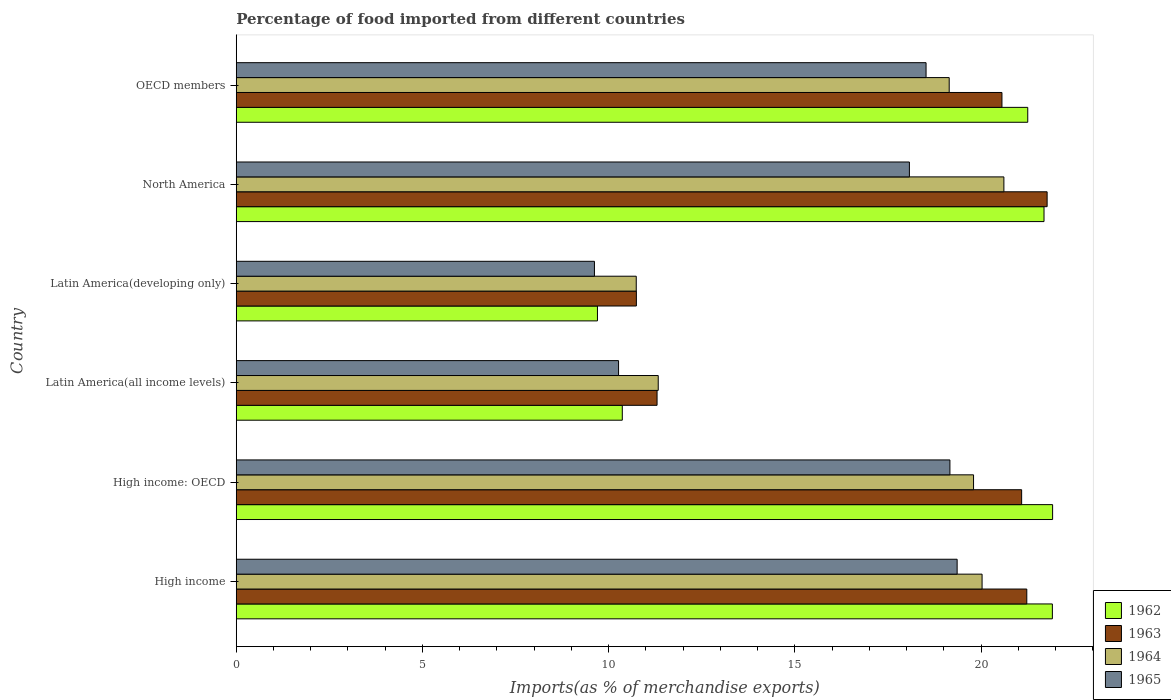Are the number of bars on each tick of the Y-axis equal?
Your answer should be very brief. Yes. How many bars are there on the 4th tick from the top?
Ensure brevity in your answer.  4. What is the label of the 5th group of bars from the top?
Provide a short and direct response. High income: OECD. What is the percentage of imports to different countries in 1964 in Latin America(developing only)?
Offer a very short reply. 10.74. Across all countries, what is the maximum percentage of imports to different countries in 1963?
Provide a succinct answer. 21.77. Across all countries, what is the minimum percentage of imports to different countries in 1965?
Make the answer very short. 9.62. In which country was the percentage of imports to different countries in 1964 maximum?
Provide a short and direct response. North America. In which country was the percentage of imports to different countries in 1962 minimum?
Offer a very short reply. Latin America(developing only). What is the total percentage of imports to different countries in 1962 in the graph?
Your answer should be very brief. 106.83. What is the difference between the percentage of imports to different countries in 1965 in High income and that in North America?
Give a very brief answer. 1.28. What is the difference between the percentage of imports to different countries in 1962 in High income and the percentage of imports to different countries in 1963 in North America?
Your answer should be very brief. 0.14. What is the average percentage of imports to different countries in 1962 per country?
Your response must be concise. 17.81. What is the difference between the percentage of imports to different countries in 1964 and percentage of imports to different countries in 1962 in North America?
Offer a very short reply. -1.08. What is the ratio of the percentage of imports to different countries in 1964 in High income: OECD to that in OECD members?
Keep it short and to the point. 1.03. What is the difference between the highest and the second highest percentage of imports to different countries in 1964?
Keep it short and to the point. 0.59. What is the difference between the highest and the lowest percentage of imports to different countries in 1963?
Your answer should be compact. 11.03. In how many countries, is the percentage of imports to different countries in 1965 greater than the average percentage of imports to different countries in 1965 taken over all countries?
Your answer should be very brief. 4. Is the sum of the percentage of imports to different countries in 1962 in Latin America(developing only) and North America greater than the maximum percentage of imports to different countries in 1964 across all countries?
Give a very brief answer. Yes. What does the 2nd bar from the top in Latin America(all income levels) represents?
Provide a succinct answer. 1964. What does the 3rd bar from the bottom in Latin America(developing only) represents?
Keep it short and to the point. 1964. How many bars are there?
Your answer should be very brief. 24. Are all the bars in the graph horizontal?
Your answer should be very brief. Yes. Are the values on the major ticks of X-axis written in scientific E-notation?
Provide a short and direct response. No. Where does the legend appear in the graph?
Make the answer very short. Bottom right. What is the title of the graph?
Your answer should be compact. Percentage of food imported from different countries. Does "1984" appear as one of the legend labels in the graph?
Give a very brief answer. No. What is the label or title of the X-axis?
Your response must be concise. Imports(as % of merchandise exports). What is the label or title of the Y-axis?
Offer a very short reply. Country. What is the Imports(as % of merchandise exports) in 1962 in High income?
Your answer should be very brief. 21.91. What is the Imports(as % of merchandise exports) in 1963 in High income?
Give a very brief answer. 21.23. What is the Imports(as % of merchandise exports) of 1964 in High income?
Provide a short and direct response. 20.02. What is the Imports(as % of merchandise exports) in 1965 in High income?
Keep it short and to the point. 19.36. What is the Imports(as % of merchandise exports) of 1962 in High income: OECD?
Provide a short and direct response. 21.92. What is the Imports(as % of merchandise exports) of 1963 in High income: OECD?
Offer a terse response. 21.09. What is the Imports(as % of merchandise exports) of 1964 in High income: OECD?
Give a very brief answer. 19.8. What is the Imports(as % of merchandise exports) of 1965 in High income: OECD?
Ensure brevity in your answer.  19.16. What is the Imports(as % of merchandise exports) in 1962 in Latin America(all income levels)?
Your answer should be very brief. 10.36. What is the Imports(as % of merchandise exports) in 1963 in Latin America(all income levels)?
Keep it short and to the point. 11.3. What is the Imports(as % of merchandise exports) of 1964 in Latin America(all income levels)?
Provide a succinct answer. 11.33. What is the Imports(as % of merchandise exports) in 1965 in Latin America(all income levels)?
Give a very brief answer. 10.26. What is the Imports(as % of merchandise exports) of 1962 in Latin America(developing only)?
Your answer should be compact. 9.7. What is the Imports(as % of merchandise exports) in 1963 in Latin America(developing only)?
Offer a very short reply. 10.74. What is the Imports(as % of merchandise exports) of 1964 in Latin America(developing only)?
Provide a short and direct response. 10.74. What is the Imports(as % of merchandise exports) in 1965 in Latin America(developing only)?
Ensure brevity in your answer.  9.62. What is the Imports(as % of merchandise exports) in 1962 in North America?
Give a very brief answer. 21.69. What is the Imports(as % of merchandise exports) in 1963 in North America?
Provide a succinct answer. 21.77. What is the Imports(as % of merchandise exports) of 1964 in North America?
Your answer should be compact. 20.61. What is the Imports(as % of merchandise exports) in 1965 in North America?
Give a very brief answer. 18.07. What is the Imports(as % of merchandise exports) in 1962 in OECD members?
Your answer should be compact. 21.25. What is the Imports(as % of merchandise exports) of 1963 in OECD members?
Your response must be concise. 20.56. What is the Imports(as % of merchandise exports) in 1964 in OECD members?
Give a very brief answer. 19.14. What is the Imports(as % of merchandise exports) in 1965 in OECD members?
Offer a terse response. 18.52. Across all countries, what is the maximum Imports(as % of merchandise exports) of 1962?
Keep it short and to the point. 21.92. Across all countries, what is the maximum Imports(as % of merchandise exports) in 1963?
Offer a very short reply. 21.77. Across all countries, what is the maximum Imports(as % of merchandise exports) of 1964?
Your answer should be very brief. 20.61. Across all countries, what is the maximum Imports(as % of merchandise exports) in 1965?
Keep it short and to the point. 19.36. Across all countries, what is the minimum Imports(as % of merchandise exports) in 1962?
Your response must be concise. 9.7. Across all countries, what is the minimum Imports(as % of merchandise exports) in 1963?
Your answer should be compact. 10.74. Across all countries, what is the minimum Imports(as % of merchandise exports) of 1964?
Offer a very short reply. 10.74. Across all countries, what is the minimum Imports(as % of merchandise exports) of 1965?
Offer a very short reply. 9.62. What is the total Imports(as % of merchandise exports) of 1962 in the graph?
Give a very brief answer. 106.83. What is the total Imports(as % of merchandise exports) in 1963 in the graph?
Make the answer very short. 106.68. What is the total Imports(as % of merchandise exports) in 1964 in the graph?
Keep it short and to the point. 101.64. What is the total Imports(as % of merchandise exports) of 1965 in the graph?
Your answer should be compact. 94.99. What is the difference between the Imports(as % of merchandise exports) of 1962 in High income and that in High income: OECD?
Ensure brevity in your answer.  -0.01. What is the difference between the Imports(as % of merchandise exports) of 1963 in High income and that in High income: OECD?
Offer a terse response. 0.14. What is the difference between the Imports(as % of merchandise exports) of 1964 in High income and that in High income: OECD?
Your answer should be very brief. 0.23. What is the difference between the Imports(as % of merchandise exports) in 1965 in High income and that in High income: OECD?
Provide a short and direct response. 0.19. What is the difference between the Imports(as % of merchandise exports) of 1962 in High income and that in Latin America(all income levels)?
Your answer should be compact. 11.55. What is the difference between the Imports(as % of merchandise exports) in 1963 in High income and that in Latin America(all income levels)?
Offer a very short reply. 9.93. What is the difference between the Imports(as % of merchandise exports) of 1964 in High income and that in Latin America(all income levels)?
Your response must be concise. 8.7. What is the difference between the Imports(as % of merchandise exports) of 1965 in High income and that in Latin America(all income levels)?
Your answer should be very brief. 9.09. What is the difference between the Imports(as % of merchandise exports) of 1962 in High income and that in Latin America(developing only)?
Your response must be concise. 12.21. What is the difference between the Imports(as % of merchandise exports) in 1963 in High income and that in Latin America(developing only)?
Give a very brief answer. 10.48. What is the difference between the Imports(as % of merchandise exports) of 1964 in High income and that in Latin America(developing only)?
Your answer should be very brief. 9.29. What is the difference between the Imports(as % of merchandise exports) in 1965 in High income and that in Latin America(developing only)?
Provide a short and direct response. 9.74. What is the difference between the Imports(as % of merchandise exports) of 1962 in High income and that in North America?
Provide a succinct answer. 0.22. What is the difference between the Imports(as % of merchandise exports) in 1963 in High income and that in North America?
Provide a succinct answer. -0.55. What is the difference between the Imports(as % of merchandise exports) of 1964 in High income and that in North America?
Give a very brief answer. -0.59. What is the difference between the Imports(as % of merchandise exports) of 1965 in High income and that in North America?
Ensure brevity in your answer.  1.28. What is the difference between the Imports(as % of merchandise exports) in 1962 in High income and that in OECD members?
Give a very brief answer. 0.66. What is the difference between the Imports(as % of merchandise exports) of 1963 in High income and that in OECD members?
Offer a very short reply. 0.67. What is the difference between the Imports(as % of merchandise exports) in 1964 in High income and that in OECD members?
Make the answer very short. 0.88. What is the difference between the Imports(as % of merchandise exports) in 1965 in High income and that in OECD members?
Your response must be concise. 0.83. What is the difference between the Imports(as % of merchandise exports) in 1962 in High income: OECD and that in Latin America(all income levels)?
Offer a very short reply. 11.55. What is the difference between the Imports(as % of merchandise exports) of 1963 in High income: OECD and that in Latin America(all income levels)?
Your answer should be compact. 9.79. What is the difference between the Imports(as % of merchandise exports) of 1964 in High income: OECD and that in Latin America(all income levels)?
Provide a short and direct response. 8.47. What is the difference between the Imports(as % of merchandise exports) in 1965 in High income: OECD and that in Latin America(all income levels)?
Offer a very short reply. 8.9. What is the difference between the Imports(as % of merchandise exports) of 1962 in High income: OECD and that in Latin America(developing only)?
Give a very brief answer. 12.22. What is the difference between the Imports(as % of merchandise exports) in 1963 in High income: OECD and that in Latin America(developing only)?
Make the answer very short. 10.34. What is the difference between the Imports(as % of merchandise exports) in 1964 in High income: OECD and that in Latin America(developing only)?
Ensure brevity in your answer.  9.06. What is the difference between the Imports(as % of merchandise exports) in 1965 in High income: OECD and that in Latin America(developing only)?
Provide a short and direct response. 9.54. What is the difference between the Imports(as % of merchandise exports) in 1962 in High income: OECD and that in North America?
Keep it short and to the point. 0.23. What is the difference between the Imports(as % of merchandise exports) of 1963 in High income: OECD and that in North America?
Give a very brief answer. -0.68. What is the difference between the Imports(as % of merchandise exports) of 1964 in High income: OECD and that in North America?
Provide a short and direct response. -0.81. What is the difference between the Imports(as % of merchandise exports) of 1965 in High income: OECD and that in North America?
Your response must be concise. 1.09. What is the difference between the Imports(as % of merchandise exports) in 1962 in High income: OECD and that in OECD members?
Keep it short and to the point. 0.67. What is the difference between the Imports(as % of merchandise exports) of 1963 in High income: OECD and that in OECD members?
Provide a succinct answer. 0.53. What is the difference between the Imports(as % of merchandise exports) of 1964 in High income: OECD and that in OECD members?
Ensure brevity in your answer.  0.65. What is the difference between the Imports(as % of merchandise exports) in 1965 in High income: OECD and that in OECD members?
Your answer should be compact. 0.64. What is the difference between the Imports(as % of merchandise exports) of 1962 in Latin America(all income levels) and that in Latin America(developing only)?
Give a very brief answer. 0.67. What is the difference between the Imports(as % of merchandise exports) in 1963 in Latin America(all income levels) and that in Latin America(developing only)?
Make the answer very short. 0.56. What is the difference between the Imports(as % of merchandise exports) of 1964 in Latin America(all income levels) and that in Latin America(developing only)?
Give a very brief answer. 0.59. What is the difference between the Imports(as % of merchandise exports) of 1965 in Latin America(all income levels) and that in Latin America(developing only)?
Ensure brevity in your answer.  0.65. What is the difference between the Imports(as % of merchandise exports) of 1962 in Latin America(all income levels) and that in North America?
Your response must be concise. -11.32. What is the difference between the Imports(as % of merchandise exports) in 1963 in Latin America(all income levels) and that in North America?
Offer a terse response. -10.47. What is the difference between the Imports(as % of merchandise exports) in 1964 in Latin America(all income levels) and that in North America?
Your response must be concise. -9.28. What is the difference between the Imports(as % of merchandise exports) in 1965 in Latin America(all income levels) and that in North America?
Ensure brevity in your answer.  -7.81. What is the difference between the Imports(as % of merchandise exports) of 1962 in Latin America(all income levels) and that in OECD members?
Provide a succinct answer. -10.89. What is the difference between the Imports(as % of merchandise exports) of 1963 in Latin America(all income levels) and that in OECD members?
Give a very brief answer. -9.26. What is the difference between the Imports(as % of merchandise exports) in 1964 in Latin America(all income levels) and that in OECD members?
Provide a succinct answer. -7.81. What is the difference between the Imports(as % of merchandise exports) of 1965 in Latin America(all income levels) and that in OECD members?
Your answer should be very brief. -8.26. What is the difference between the Imports(as % of merchandise exports) of 1962 in Latin America(developing only) and that in North America?
Provide a short and direct response. -11.99. What is the difference between the Imports(as % of merchandise exports) of 1963 in Latin America(developing only) and that in North America?
Provide a short and direct response. -11.03. What is the difference between the Imports(as % of merchandise exports) of 1964 in Latin America(developing only) and that in North America?
Give a very brief answer. -9.87. What is the difference between the Imports(as % of merchandise exports) of 1965 in Latin America(developing only) and that in North America?
Provide a short and direct response. -8.46. What is the difference between the Imports(as % of merchandise exports) in 1962 in Latin America(developing only) and that in OECD members?
Make the answer very short. -11.55. What is the difference between the Imports(as % of merchandise exports) in 1963 in Latin America(developing only) and that in OECD members?
Provide a succinct answer. -9.82. What is the difference between the Imports(as % of merchandise exports) of 1964 in Latin America(developing only) and that in OECD members?
Offer a very short reply. -8.4. What is the difference between the Imports(as % of merchandise exports) in 1965 in Latin America(developing only) and that in OECD members?
Offer a very short reply. -8.9. What is the difference between the Imports(as % of merchandise exports) in 1962 in North America and that in OECD members?
Make the answer very short. 0.44. What is the difference between the Imports(as % of merchandise exports) of 1963 in North America and that in OECD members?
Give a very brief answer. 1.21. What is the difference between the Imports(as % of merchandise exports) of 1964 in North America and that in OECD members?
Ensure brevity in your answer.  1.47. What is the difference between the Imports(as % of merchandise exports) in 1965 in North America and that in OECD members?
Make the answer very short. -0.45. What is the difference between the Imports(as % of merchandise exports) in 1962 in High income and the Imports(as % of merchandise exports) in 1963 in High income: OECD?
Your answer should be compact. 0.83. What is the difference between the Imports(as % of merchandise exports) of 1962 in High income and the Imports(as % of merchandise exports) of 1964 in High income: OECD?
Keep it short and to the point. 2.12. What is the difference between the Imports(as % of merchandise exports) in 1962 in High income and the Imports(as % of merchandise exports) in 1965 in High income: OECD?
Make the answer very short. 2.75. What is the difference between the Imports(as % of merchandise exports) of 1963 in High income and the Imports(as % of merchandise exports) of 1964 in High income: OECD?
Make the answer very short. 1.43. What is the difference between the Imports(as % of merchandise exports) of 1963 in High income and the Imports(as % of merchandise exports) of 1965 in High income: OECD?
Provide a succinct answer. 2.06. What is the difference between the Imports(as % of merchandise exports) in 1964 in High income and the Imports(as % of merchandise exports) in 1965 in High income: OECD?
Give a very brief answer. 0.86. What is the difference between the Imports(as % of merchandise exports) of 1962 in High income and the Imports(as % of merchandise exports) of 1963 in Latin America(all income levels)?
Give a very brief answer. 10.61. What is the difference between the Imports(as % of merchandise exports) in 1962 in High income and the Imports(as % of merchandise exports) in 1964 in Latin America(all income levels)?
Provide a short and direct response. 10.58. What is the difference between the Imports(as % of merchandise exports) in 1962 in High income and the Imports(as % of merchandise exports) in 1965 in Latin America(all income levels)?
Provide a succinct answer. 11.65. What is the difference between the Imports(as % of merchandise exports) in 1963 in High income and the Imports(as % of merchandise exports) in 1964 in Latin America(all income levels)?
Keep it short and to the point. 9.9. What is the difference between the Imports(as % of merchandise exports) of 1963 in High income and the Imports(as % of merchandise exports) of 1965 in Latin America(all income levels)?
Your answer should be very brief. 10.96. What is the difference between the Imports(as % of merchandise exports) of 1964 in High income and the Imports(as % of merchandise exports) of 1965 in Latin America(all income levels)?
Keep it short and to the point. 9.76. What is the difference between the Imports(as % of merchandise exports) in 1962 in High income and the Imports(as % of merchandise exports) in 1963 in Latin America(developing only)?
Ensure brevity in your answer.  11.17. What is the difference between the Imports(as % of merchandise exports) in 1962 in High income and the Imports(as % of merchandise exports) in 1964 in Latin America(developing only)?
Provide a short and direct response. 11.17. What is the difference between the Imports(as % of merchandise exports) in 1962 in High income and the Imports(as % of merchandise exports) in 1965 in Latin America(developing only)?
Make the answer very short. 12.3. What is the difference between the Imports(as % of merchandise exports) in 1963 in High income and the Imports(as % of merchandise exports) in 1964 in Latin America(developing only)?
Ensure brevity in your answer.  10.49. What is the difference between the Imports(as % of merchandise exports) in 1963 in High income and the Imports(as % of merchandise exports) in 1965 in Latin America(developing only)?
Provide a succinct answer. 11.61. What is the difference between the Imports(as % of merchandise exports) of 1964 in High income and the Imports(as % of merchandise exports) of 1965 in Latin America(developing only)?
Give a very brief answer. 10.41. What is the difference between the Imports(as % of merchandise exports) in 1962 in High income and the Imports(as % of merchandise exports) in 1963 in North America?
Your response must be concise. 0.14. What is the difference between the Imports(as % of merchandise exports) of 1962 in High income and the Imports(as % of merchandise exports) of 1964 in North America?
Ensure brevity in your answer.  1.3. What is the difference between the Imports(as % of merchandise exports) of 1962 in High income and the Imports(as % of merchandise exports) of 1965 in North America?
Offer a terse response. 3.84. What is the difference between the Imports(as % of merchandise exports) in 1963 in High income and the Imports(as % of merchandise exports) in 1964 in North America?
Make the answer very short. 0.61. What is the difference between the Imports(as % of merchandise exports) in 1963 in High income and the Imports(as % of merchandise exports) in 1965 in North America?
Offer a terse response. 3.15. What is the difference between the Imports(as % of merchandise exports) of 1964 in High income and the Imports(as % of merchandise exports) of 1965 in North America?
Offer a very short reply. 1.95. What is the difference between the Imports(as % of merchandise exports) in 1962 in High income and the Imports(as % of merchandise exports) in 1963 in OECD members?
Offer a very short reply. 1.35. What is the difference between the Imports(as % of merchandise exports) of 1962 in High income and the Imports(as % of merchandise exports) of 1964 in OECD members?
Give a very brief answer. 2.77. What is the difference between the Imports(as % of merchandise exports) of 1962 in High income and the Imports(as % of merchandise exports) of 1965 in OECD members?
Make the answer very short. 3.39. What is the difference between the Imports(as % of merchandise exports) in 1963 in High income and the Imports(as % of merchandise exports) in 1964 in OECD members?
Offer a terse response. 2.08. What is the difference between the Imports(as % of merchandise exports) in 1963 in High income and the Imports(as % of merchandise exports) in 1965 in OECD members?
Your answer should be compact. 2.7. What is the difference between the Imports(as % of merchandise exports) in 1964 in High income and the Imports(as % of merchandise exports) in 1965 in OECD members?
Your answer should be compact. 1.5. What is the difference between the Imports(as % of merchandise exports) of 1962 in High income: OECD and the Imports(as % of merchandise exports) of 1963 in Latin America(all income levels)?
Keep it short and to the point. 10.62. What is the difference between the Imports(as % of merchandise exports) of 1962 in High income: OECD and the Imports(as % of merchandise exports) of 1964 in Latin America(all income levels)?
Provide a succinct answer. 10.59. What is the difference between the Imports(as % of merchandise exports) in 1962 in High income: OECD and the Imports(as % of merchandise exports) in 1965 in Latin America(all income levels)?
Give a very brief answer. 11.65. What is the difference between the Imports(as % of merchandise exports) of 1963 in High income: OECD and the Imports(as % of merchandise exports) of 1964 in Latin America(all income levels)?
Ensure brevity in your answer.  9.76. What is the difference between the Imports(as % of merchandise exports) in 1963 in High income: OECD and the Imports(as % of merchandise exports) in 1965 in Latin America(all income levels)?
Your answer should be compact. 10.82. What is the difference between the Imports(as % of merchandise exports) of 1964 in High income: OECD and the Imports(as % of merchandise exports) of 1965 in Latin America(all income levels)?
Offer a very short reply. 9.53. What is the difference between the Imports(as % of merchandise exports) of 1962 in High income: OECD and the Imports(as % of merchandise exports) of 1963 in Latin America(developing only)?
Make the answer very short. 11.18. What is the difference between the Imports(as % of merchandise exports) of 1962 in High income: OECD and the Imports(as % of merchandise exports) of 1964 in Latin America(developing only)?
Give a very brief answer. 11.18. What is the difference between the Imports(as % of merchandise exports) of 1962 in High income: OECD and the Imports(as % of merchandise exports) of 1965 in Latin America(developing only)?
Provide a short and direct response. 12.3. What is the difference between the Imports(as % of merchandise exports) in 1963 in High income: OECD and the Imports(as % of merchandise exports) in 1964 in Latin America(developing only)?
Offer a very short reply. 10.35. What is the difference between the Imports(as % of merchandise exports) of 1963 in High income: OECD and the Imports(as % of merchandise exports) of 1965 in Latin America(developing only)?
Make the answer very short. 11.47. What is the difference between the Imports(as % of merchandise exports) of 1964 in High income: OECD and the Imports(as % of merchandise exports) of 1965 in Latin America(developing only)?
Give a very brief answer. 10.18. What is the difference between the Imports(as % of merchandise exports) of 1962 in High income: OECD and the Imports(as % of merchandise exports) of 1963 in North America?
Make the answer very short. 0.15. What is the difference between the Imports(as % of merchandise exports) in 1962 in High income: OECD and the Imports(as % of merchandise exports) in 1964 in North America?
Offer a terse response. 1.31. What is the difference between the Imports(as % of merchandise exports) in 1962 in High income: OECD and the Imports(as % of merchandise exports) in 1965 in North America?
Give a very brief answer. 3.84. What is the difference between the Imports(as % of merchandise exports) of 1963 in High income: OECD and the Imports(as % of merchandise exports) of 1964 in North America?
Give a very brief answer. 0.48. What is the difference between the Imports(as % of merchandise exports) in 1963 in High income: OECD and the Imports(as % of merchandise exports) in 1965 in North America?
Your answer should be very brief. 3.01. What is the difference between the Imports(as % of merchandise exports) in 1964 in High income: OECD and the Imports(as % of merchandise exports) in 1965 in North America?
Make the answer very short. 1.72. What is the difference between the Imports(as % of merchandise exports) of 1962 in High income: OECD and the Imports(as % of merchandise exports) of 1963 in OECD members?
Give a very brief answer. 1.36. What is the difference between the Imports(as % of merchandise exports) in 1962 in High income: OECD and the Imports(as % of merchandise exports) in 1964 in OECD members?
Keep it short and to the point. 2.78. What is the difference between the Imports(as % of merchandise exports) in 1962 in High income: OECD and the Imports(as % of merchandise exports) in 1965 in OECD members?
Your response must be concise. 3.4. What is the difference between the Imports(as % of merchandise exports) in 1963 in High income: OECD and the Imports(as % of merchandise exports) in 1964 in OECD members?
Your answer should be compact. 1.94. What is the difference between the Imports(as % of merchandise exports) of 1963 in High income: OECD and the Imports(as % of merchandise exports) of 1965 in OECD members?
Make the answer very short. 2.57. What is the difference between the Imports(as % of merchandise exports) in 1964 in High income: OECD and the Imports(as % of merchandise exports) in 1965 in OECD members?
Keep it short and to the point. 1.27. What is the difference between the Imports(as % of merchandise exports) in 1962 in Latin America(all income levels) and the Imports(as % of merchandise exports) in 1963 in Latin America(developing only)?
Your response must be concise. -0.38. What is the difference between the Imports(as % of merchandise exports) in 1962 in Latin America(all income levels) and the Imports(as % of merchandise exports) in 1964 in Latin America(developing only)?
Provide a short and direct response. -0.37. What is the difference between the Imports(as % of merchandise exports) of 1962 in Latin America(all income levels) and the Imports(as % of merchandise exports) of 1965 in Latin America(developing only)?
Ensure brevity in your answer.  0.75. What is the difference between the Imports(as % of merchandise exports) of 1963 in Latin America(all income levels) and the Imports(as % of merchandise exports) of 1964 in Latin America(developing only)?
Provide a short and direct response. 0.56. What is the difference between the Imports(as % of merchandise exports) in 1963 in Latin America(all income levels) and the Imports(as % of merchandise exports) in 1965 in Latin America(developing only)?
Your answer should be very brief. 1.68. What is the difference between the Imports(as % of merchandise exports) in 1964 in Latin America(all income levels) and the Imports(as % of merchandise exports) in 1965 in Latin America(developing only)?
Make the answer very short. 1.71. What is the difference between the Imports(as % of merchandise exports) in 1962 in Latin America(all income levels) and the Imports(as % of merchandise exports) in 1963 in North America?
Make the answer very short. -11.41. What is the difference between the Imports(as % of merchandise exports) in 1962 in Latin America(all income levels) and the Imports(as % of merchandise exports) in 1964 in North America?
Provide a short and direct response. -10.25. What is the difference between the Imports(as % of merchandise exports) of 1962 in Latin America(all income levels) and the Imports(as % of merchandise exports) of 1965 in North America?
Give a very brief answer. -7.71. What is the difference between the Imports(as % of merchandise exports) of 1963 in Latin America(all income levels) and the Imports(as % of merchandise exports) of 1964 in North America?
Keep it short and to the point. -9.31. What is the difference between the Imports(as % of merchandise exports) of 1963 in Latin America(all income levels) and the Imports(as % of merchandise exports) of 1965 in North America?
Your response must be concise. -6.78. What is the difference between the Imports(as % of merchandise exports) of 1964 in Latin America(all income levels) and the Imports(as % of merchandise exports) of 1965 in North America?
Offer a terse response. -6.74. What is the difference between the Imports(as % of merchandise exports) in 1962 in Latin America(all income levels) and the Imports(as % of merchandise exports) in 1963 in OECD members?
Give a very brief answer. -10.19. What is the difference between the Imports(as % of merchandise exports) in 1962 in Latin America(all income levels) and the Imports(as % of merchandise exports) in 1964 in OECD members?
Your answer should be compact. -8.78. What is the difference between the Imports(as % of merchandise exports) in 1962 in Latin America(all income levels) and the Imports(as % of merchandise exports) in 1965 in OECD members?
Your answer should be compact. -8.16. What is the difference between the Imports(as % of merchandise exports) in 1963 in Latin America(all income levels) and the Imports(as % of merchandise exports) in 1964 in OECD members?
Provide a short and direct response. -7.84. What is the difference between the Imports(as % of merchandise exports) in 1963 in Latin America(all income levels) and the Imports(as % of merchandise exports) in 1965 in OECD members?
Your response must be concise. -7.22. What is the difference between the Imports(as % of merchandise exports) in 1964 in Latin America(all income levels) and the Imports(as % of merchandise exports) in 1965 in OECD members?
Make the answer very short. -7.19. What is the difference between the Imports(as % of merchandise exports) of 1962 in Latin America(developing only) and the Imports(as % of merchandise exports) of 1963 in North America?
Provide a short and direct response. -12.07. What is the difference between the Imports(as % of merchandise exports) in 1962 in Latin America(developing only) and the Imports(as % of merchandise exports) in 1964 in North America?
Offer a very short reply. -10.91. What is the difference between the Imports(as % of merchandise exports) in 1962 in Latin America(developing only) and the Imports(as % of merchandise exports) in 1965 in North America?
Offer a very short reply. -8.38. What is the difference between the Imports(as % of merchandise exports) of 1963 in Latin America(developing only) and the Imports(as % of merchandise exports) of 1964 in North America?
Keep it short and to the point. -9.87. What is the difference between the Imports(as % of merchandise exports) of 1963 in Latin America(developing only) and the Imports(as % of merchandise exports) of 1965 in North America?
Keep it short and to the point. -7.33. What is the difference between the Imports(as % of merchandise exports) in 1964 in Latin America(developing only) and the Imports(as % of merchandise exports) in 1965 in North America?
Your answer should be compact. -7.33. What is the difference between the Imports(as % of merchandise exports) of 1962 in Latin America(developing only) and the Imports(as % of merchandise exports) of 1963 in OECD members?
Offer a terse response. -10.86. What is the difference between the Imports(as % of merchandise exports) of 1962 in Latin America(developing only) and the Imports(as % of merchandise exports) of 1964 in OECD members?
Provide a short and direct response. -9.44. What is the difference between the Imports(as % of merchandise exports) of 1962 in Latin America(developing only) and the Imports(as % of merchandise exports) of 1965 in OECD members?
Your answer should be very brief. -8.82. What is the difference between the Imports(as % of merchandise exports) in 1963 in Latin America(developing only) and the Imports(as % of merchandise exports) in 1964 in OECD members?
Offer a terse response. -8.4. What is the difference between the Imports(as % of merchandise exports) of 1963 in Latin America(developing only) and the Imports(as % of merchandise exports) of 1965 in OECD members?
Your answer should be very brief. -7.78. What is the difference between the Imports(as % of merchandise exports) of 1964 in Latin America(developing only) and the Imports(as % of merchandise exports) of 1965 in OECD members?
Keep it short and to the point. -7.78. What is the difference between the Imports(as % of merchandise exports) of 1962 in North America and the Imports(as % of merchandise exports) of 1963 in OECD members?
Your answer should be compact. 1.13. What is the difference between the Imports(as % of merchandise exports) of 1962 in North America and the Imports(as % of merchandise exports) of 1964 in OECD members?
Give a very brief answer. 2.55. What is the difference between the Imports(as % of merchandise exports) in 1962 in North America and the Imports(as % of merchandise exports) in 1965 in OECD members?
Your answer should be compact. 3.17. What is the difference between the Imports(as % of merchandise exports) in 1963 in North America and the Imports(as % of merchandise exports) in 1964 in OECD members?
Your answer should be compact. 2.63. What is the difference between the Imports(as % of merchandise exports) in 1963 in North America and the Imports(as % of merchandise exports) in 1965 in OECD members?
Make the answer very short. 3.25. What is the difference between the Imports(as % of merchandise exports) in 1964 in North America and the Imports(as % of merchandise exports) in 1965 in OECD members?
Offer a very short reply. 2.09. What is the average Imports(as % of merchandise exports) in 1962 per country?
Provide a short and direct response. 17.81. What is the average Imports(as % of merchandise exports) in 1963 per country?
Keep it short and to the point. 17.78. What is the average Imports(as % of merchandise exports) of 1964 per country?
Ensure brevity in your answer.  16.94. What is the average Imports(as % of merchandise exports) of 1965 per country?
Keep it short and to the point. 15.83. What is the difference between the Imports(as % of merchandise exports) in 1962 and Imports(as % of merchandise exports) in 1963 in High income?
Your answer should be compact. 0.69. What is the difference between the Imports(as % of merchandise exports) of 1962 and Imports(as % of merchandise exports) of 1964 in High income?
Offer a very short reply. 1.89. What is the difference between the Imports(as % of merchandise exports) in 1962 and Imports(as % of merchandise exports) in 1965 in High income?
Your response must be concise. 2.56. What is the difference between the Imports(as % of merchandise exports) in 1963 and Imports(as % of merchandise exports) in 1964 in High income?
Your answer should be compact. 1.2. What is the difference between the Imports(as % of merchandise exports) of 1963 and Imports(as % of merchandise exports) of 1965 in High income?
Give a very brief answer. 1.87. What is the difference between the Imports(as % of merchandise exports) of 1964 and Imports(as % of merchandise exports) of 1965 in High income?
Offer a terse response. 0.67. What is the difference between the Imports(as % of merchandise exports) in 1962 and Imports(as % of merchandise exports) in 1963 in High income: OECD?
Provide a short and direct response. 0.83. What is the difference between the Imports(as % of merchandise exports) of 1962 and Imports(as % of merchandise exports) of 1964 in High income: OECD?
Your response must be concise. 2.12. What is the difference between the Imports(as % of merchandise exports) in 1962 and Imports(as % of merchandise exports) in 1965 in High income: OECD?
Offer a very short reply. 2.76. What is the difference between the Imports(as % of merchandise exports) in 1963 and Imports(as % of merchandise exports) in 1964 in High income: OECD?
Offer a terse response. 1.29. What is the difference between the Imports(as % of merchandise exports) in 1963 and Imports(as % of merchandise exports) in 1965 in High income: OECD?
Offer a very short reply. 1.93. What is the difference between the Imports(as % of merchandise exports) of 1964 and Imports(as % of merchandise exports) of 1965 in High income: OECD?
Provide a short and direct response. 0.63. What is the difference between the Imports(as % of merchandise exports) in 1962 and Imports(as % of merchandise exports) in 1963 in Latin America(all income levels)?
Your answer should be compact. -0.93. What is the difference between the Imports(as % of merchandise exports) of 1962 and Imports(as % of merchandise exports) of 1964 in Latin America(all income levels)?
Ensure brevity in your answer.  -0.96. What is the difference between the Imports(as % of merchandise exports) of 1962 and Imports(as % of merchandise exports) of 1965 in Latin America(all income levels)?
Make the answer very short. 0.1. What is the difference between the Imports(as % of merchandise exports) of 1963 and Imports(as % of merchandise exports) of 1964 in Latin America(all income levels)?
Your answer should be compact. -0.03. What is the difference between the Imports(as % of merchandise exports) in 1963 and Imports(as % of merchandise exports) in 1965 in Latin America(all income levels)?
Provide a succinct answer. 1.03. What is the difference between the Imports(as % of merchandise exports) of 1964 and Imports(as % of merchandise exports) of 1965 in Latin America(all income levels)?
Provide a succinct answer. 1.07. What is the difference between the Imports(as % of merchandise exports) in 1962 and Imports(as % of merchandise exports) in 1963 in Latin America(developing only)?
Offer a terse response. -1.05. What is the difference between the Imports(as % of merchandise exports) in 1962 and Imports(as % of merchandise exports) in 1964 in Latin America(developing only)?
Make the answer very short. -1.04. What is the difference between the Imports(as % of merchandise exports) of 1962 and Imports(as % of merchandise exports) of 1965 in Latin America(developing only)?
Give a very brief answer. 0.08. What is the difference between the Imports(as % of merchandise exports) of 1963 and Imports(as % of merchandise exports) of 1964 in Latin America(developing only)?
Give a very brief answer. 0. What is the difference between the Imports(as % of merchandise exports) in 1963 and Imports(as % of merchandise exports) in 1965 in Latin America(developing only)?
Your answer should be very brief. 1.13. What is the difference between the Imports(as % of merchandise exports) of 1964 and Imports(as % of merchandise exports) of 1965 in Latin America(developing only)?
Provide a short and direct response. 1.12. What is the difference between the Imports(as % of merchandise exports) in 1962 and Imports(as % of merchandise exports) in 1963 in North America?
Provide a succinct answer. -0.08. What is the difference between the Imports(as % of merchandise exports) in 1962 and Imports(as % of merchandise exports) in 1964 in North America?
Your answer should be compact. 1.08. What is the difference between the Imports(as % of merchandise exports) in 1962 and Imports(as % of merchandise exports) in 1965 in North America?
Offer a very short reply. 3.61. What is the difference between the Imports(as % of merchandise exports) in 1963 and Imports(as % of merchandise exports) in 1964 in North America?
Ensure brevity in your answer.  1.16. What is the difference between the Imports(as % of merchandise exports) of 1963 and Imports(as % of merchandise exports) of 1965 in North America?
Make the answer very short. 3.7. What is the difference between the Imports(as % of merchandise exports) of 1964 and Imports(as % of merchandise exports) of 1965 in North America?
Offer a terse response. 2.54. What is the difference between the Imports(as % of merchandise exports) of 1962 and Imports(as % of merchandise exports) of 1963 in OECD members?
Keep it short and to the point. 0.69. What is the difference between the Imports(as % of merchandise exports) in 1962 and Imports(as % of merchandise exports) in 1964 in OECD members?
Provide a short and direct response. 2.11. What is the difference between the Imports(as % of merchandise exports) of 1962 and Imports(as % of merchandise exports) of 1965 in OECD members?
Ensure brevity in your answer.  2.73. What is the difference between the Imports(as % of merchandise exports) in 1963 and Imports(as % of merchandise exports) in 1964 in OECD members?
Your response must be concise. 1.42. What is the difference between the Imports(as % of merchandise exports) in 1963 and Imports(as % of merchandise exports) in 1965 in OECD members?
Offer a very short reply. 2.04. What is the difference between the Imports(as % of merchandise exports) in 1964 and Imports(as % of merchandise exports) in 1965 in OECD members?
Your answer should be compact. 0.62. What is the ratio of the Imports(as % of merchandise exports) in 1963 in High income to that in High income: OECD?
Give a very brief answer. 1.01. What is the ratio of the Imports(as % of merchandise exports) of 1964 in High income to that in High income: OECD?
Keep it short and to the point. 1.01. What is the ratio of the Imports(as % of merchandise exports) in 1965 in High income to that in High income: OECD?
Your answer should be compact. 1.01. What is the ratio of the Imports(as % of merchandise exports) of 1962 in High income to that in Latin America(all income levels)?
Give a very brief answer. 2.11. What is the ratio of the Imports(as % of merchandise exports) in 1963 in High income to that in Latin America(all income levels)?
Your answer should be very brief. 1.88. What is the ratio of the Imports(as % of merchandise exports) in 1964 in High income to that in Latin America(all income levels)?
Your answer should be compact. 1.77. What is the ratio of the Imports(as % of merchandise exports) of 1965 in High income to that in Latin America(all income levels)?
Offer a very short reply. 1.89. What is the ratio of the Imports(as % of merchandise exports) of 1962 in High income to that in Latin America(developing only)?
Ensure brevity in your answer.  2.26. What is the ratio of the Imports(as % of merchandise exports) in 1963 in High income to that in Latin America(developing only)?
Provide a succinct answer. 1.98. What is the ratio of the Imports(as % of merchandise exports) in 1964 in High income to that in Latin America(developing only)?
Your response must be concise. 1.86. What is the ratio of the Imports(as % of merchandise exports) in 1965 in High income to that in Latin America(developing only)?
Your answer should be compact. 2.01. What is the ratio of the Imports(as % of merchandise exports) in 1962 in High income to that in North America?
Your answer should be compact. 1.01. What is the ratio of the Imports(as % of merchandise exports) of 1963 in High income to that in North America?
Offer a very short reply. 0.97. What is the ratio of the Imports(as % of merchandise exports) of 1964 in High income to that in North America?
Your answer should be compact. 0.97. What is the ratio of the Imports(as % of merchandise exports) of 1965 in High income to that in North America?
Make the answer very short. 1.07. What is the ratio of the Imports(as % of merchandise exports) in 1962 in High income to that in OECD members?
Ensure brevity in your answer.  1.03. What is the ratio of the Imports(as % of merchandise exports) in 1963 in High income to that in OECD members?
Your answer should be very brief. 1.03. What is the ratio of the Imports(as % of merchandise exports) in 1964 in High income to that in OECD members?
Give a very brief answer. 1.05. What is the ratio of the Imports(as % of merchandise exports) in 1965 in High income to that in OECD members?
Offer a terse response. 1.05. What is the ratio of the Imports(as % of merchandise exports) in 1962 in High income: OECD to that in Latin America(all income levels)?
Make the answer very short. 2.11. What is the ratio of the Imports(as % of merchandise exports) in 1963 in High income: OECD to that in Latin America(all income levels)?
Offer a terse response. 1.87. What is the ratio of the Imports(as % of merchandise exports) in 1964 in High income: OECD to that in Latin America(all income levels)?
Ensure brevity in your answer.  1.75. What is the ratio of the Imports(as % of merchandise exports) in 1965 in High income: OECD to that in Latin America(all income levels)?
Make the answer very short. 1.87. What is the ratio of the Imports(as % of merchandise exports) of 1962 in High income: OECD to that in Latin America(developing only)?
Your answer should be very brief. 2.26. What is the ratio of the Imports(as % of merchandise exports) of 1963 in High income: OECD to that in Latin America(developing only)?
Your answer should be compact. 1.96. What is the ratio of the Imports(as % of merchandise exports) in 1964 in High income: OECD to that in Latin America(developing only)?
Your response must be concise. 1.84. What is the ratio of the Imports(as % of merchandise exports) of 1965 in High income: OECD to that in Latin America(developing only)?
Offer a very short reply. 1.99. What is the ratio of the Imports(as % of merchandise exports) in 1962 in High income: OECD to that in North America?
Give a very brief answer. 1.01. What is the ratio of the Imports(as % of merchandise exports) in 1963 in High income: OECD to that in North America?
Ensure brevity in your answer.  0.97. What is the ratio of the Imports(as % of merchandise exports) in 1964 in High income: OECD to that in North America?
Give a very brief answer. 0.96. What is the ratio of the Imports(as % of merchandise exports) of 1965 in High income: OECD to that in North America?
Offer a terse response. 1.06. What is the ratio of the Imports(as % of merchandise exports) of 1962 in High income: OECD to that in OECD members?
Give a very brief answer. 1.03. What is the ratio of the Imports(as % of merchandise exports) in 1963 in High income: OECD to that in OECD members?
Make the answer very short. 1.03. What is the ratio of the Imports(as % of merchandise exports) of 1964 in High income: OECD to that in OECD members?
Provide a succinct answer. 1.03. What is the ratio of the Imports(as % of merchandise exports) in 1965 in High income: OECD to that in OECD members?
Ensure brevity in your answer.  1.03. What is the ratio of the Imports(as % of merchandise exports) in 1962 in Latin America(all income levels) to that in Latin America(developing only)?
Your answer should be compact. 1.07. What is the ratio of the Imports(as % of merchandise exports) in 1963 in Latin America(all income levels) to that in Latin America(developing only)?
Your answer should be compact. 1.05. What is the ratio of the Imports(as % of merchandise exports) of 1964 in Latin America(all income levels) to that in Latin America(developing only)?
Give a very brief answer. 1.05. What is the ratio of the Imports(as % of merchandise exports) in 1965 in Latin America(all income levels) to that in Latin America(developing only)?
Give a very brief answer. 1.07. What is the ratio of the Imports(as % of merchandise exports) in 1962 in Latin America(all income levels) to that in North America?
Your answer should be compact. 0.48. What is the ratio of the Imports(as % of merchandise exports) of 1963 in Latin America(all income levels) to that in North America?
Offer a terse response. 0.52. What is the ratio of the Imports(as % of merchandise exports) of 1964 in Latin America(all income levels) to that in North America?
Give a very brief answer. 0.55. What is the ratio of the Imports(as % of merchandise exports) of 1965 in Latin America(all income levels) to that in North America?
Your answer should be very brief. 0.57. What is the ratio of the Imports(as % of merchandise exports) of 1962 in Latin America(all income levels) to that in OECD members?
Offer a very short reply. 0.49. What is the ratio of the Imports(as % of merchandise exports) in 1963 in Latin America(all income levels) to that in OECD members?
Make the answer very short. 0.55. What is the ratio of the Imports(as % of merchandise exports) of 1964 in Latin America(all income levels) to that in OECD members?
Your response must be concise. 0.59. What is the ratio of the Imports(as % of merchandise exports) of 1965 in Latin America(all income levels) to that in OECD members?
Provide a short and direct response. 0.55. What is the ratio of the Imports(as % of merchandise exports) in 1962 in Latin America(developing only) to that in North America?
Your response must be concise. 0.45. What is the ratio of the Imports(as % of merchandise exports) of 1963 in Latin America(developing only) to that in North America?
Provide a succinct answer. 0.49. What is the ratio of the Imports(as % of merchandise exports) of 1964 in Latin America(developing only) to that in North America?
Offer a very short reply. 0.52. What is the ratio of the Imports(as % of merchandise exports) of 1965 in Latin America(developing only) to that in North America?
Offer a very short reply. 0.53. What is the ratio of the Imports(as % of merchandise exports) in 1962 in Latin America(developing only) to that in OECD members?
Provide a short and direct response. 0.46. What is the ratio of the Imports(as % of merchandise exports) of 1963 in Latin America(developing only) to that in OECD members?
Provide a succinct answer. 0.52. What is the ratio of the Imports(as % of merchandise exports) of 1964 in Latin America(developing only) to that in OECD members?
Give a very brief answer. 0.56. What is the ratio of the Imports(as % of merchandise exports) of 1965 in Latin America(developing only) to that in OECD members?
Give a very brief answer. 0.52. What is the ratio of the Imports(as % of merchandise exports) in 1962 in North America to that in OECD members?
Offer a very short reply. 1.02. What is the ratio of the Imports(as % of merchandise exports) of 1963 in North America to that in OECD members?
Keep it short and to the point. 1.06. What is the ratio of the Imports(as % of merchandise exports) of 1964 in North America to that in OECD members?
Give a very brief answer. 1.08. What is the ratio of the Imports(as % of merchandise exports) in 1965 in North America to that in OECD members?
Provide a succinct answer. 0.98. What is the difference between the highest and the second highest Imports(as % of merchandise exports) of 1962?
Ensure brevity in your answer.  0.01. What is the difference between the highest and the second highest Imports(as % of merchandise exports) of 1963?
Give a very brief answer. 0.55. What is the difference between the highest and the second highest Imports(as % of merchandise exports) in 1964?
Provide a succinct answer. 0.59. What is the difference between the highest and the second highest Imports(as % of merchandise exports) of 1965?
Give a very brief answer. 0.19. What is the difference between the highest and the lowest Imports(as % of merchandise exports) of 1962?
Provide a succinct answer. 12.22. What is the difference between the highest and the lowest Imports(as % of merchandise exports) in 1963?
Provide a succinct answer. 11.03. What is the difference between the highest and the lowest Imports(as % of merchandise exports) in 1964?
Make the answer very short. 9.87. What is the difference between the highest and the lowest Imports(as % of merchandise exports) of 1965?
Give a very brief answer. 9.74. 